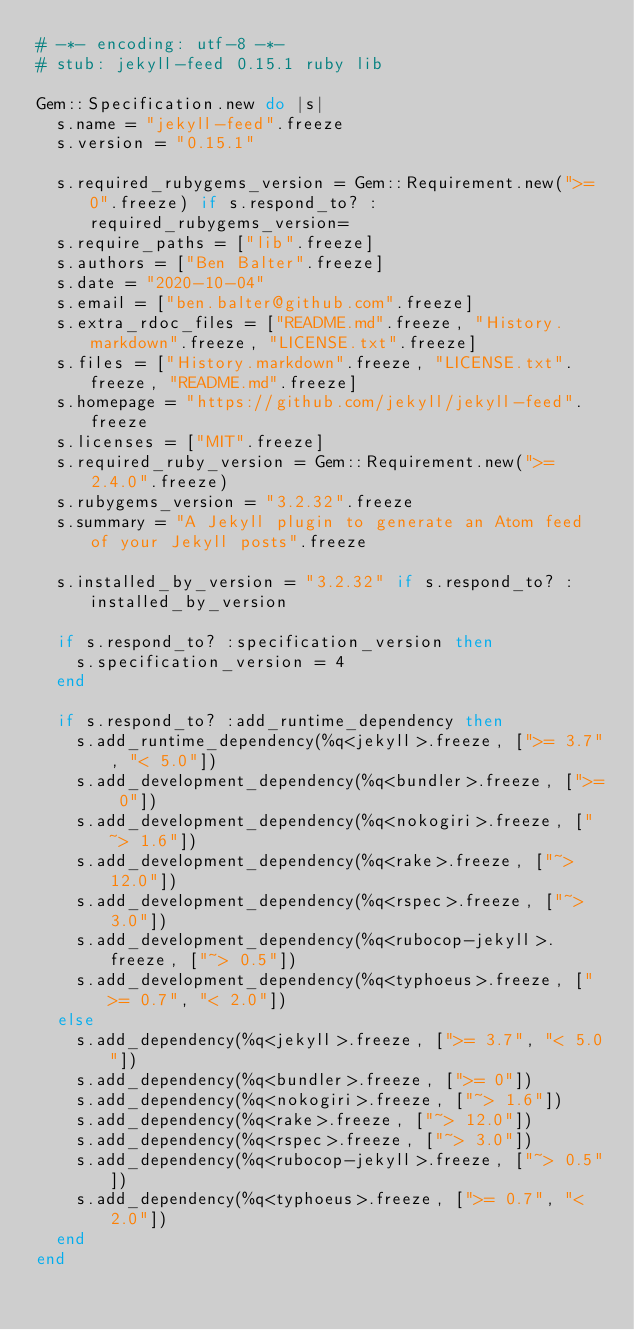Convert code to text. <code><loc_0><loc_0><loc_500><loc_500><_Ruby_># -*- encoding: utf-8 -*-
# stub: jekyll-feed 0.15.1 ruby lib

Gem::Specification.new do |s|
  s.name = "jekyll-feed".freeze
  s.version = "0.15.1"

  s.required_rubygems_version = Gem::Requirement.new(">= 0".freeze) if s.respond_to? :required_rubygems_version=
  s.require_paths = ["lib".freeze]
  s.authors = ["Ben Balter".freeze]
  s.date = "2020-10-04"
  s.email = ["ben.balter@github.com".freeze]
  s.extra_rdoc_files = ["README.md".freeze, "History.markdown".freeze, "LICENSE.txt".freeze]
  s.files = ["History.markdown".freeze, "LICENSE.txt".freeze, "README.md".freeze]
  s.homepage = "https://github.com/jekyll/jekyll-feed".freeze
  s.licenses = ["MIT".freeze]
  s.required_ruby_version = Gem::Requirement.new(">= 2.4.0".freeze)
  s.rubygems_version = "3.2.32".freeze
  s.summary = "A Jekyll plugin to generate an Atom feed of your Jekyll posts".freeze

  s.installed_by_version = "3.2.32" if s.respond_to? :installed_by_version

  if s.respond_to? :specification_version then
    s.specification_version = 4
  end

  if s.respond_to? :add_runtime_dependency then
    s.add_runtime_dependency(%q<jekyll>.freeze, [">= 3.7", "< 5.0"])
    s.add_development_dependency(%q<bundler>.freeze, [">= 0"])
    s.add_development_dependency(%q<nokogiri>.freeze, ["~> 1.6"])
    s.add_development_dependency(%q<rake>.freeze, ["~> 12.0"])
    s.add_development_dependency(%q<rspec>.freeze, ["~> 3.0"])
    s.add_development_dependency(%q<rubocop-jekyll>.freeze, ["~> 0.5"])
    s.add_development_dependency(%q<typhoeus>.freeze, [">= 0.7", "< 2.0"])
  else
    s.add_dependency(%q<jekyll>.freeze, [">= 3.7", "< 5.0"])
    s.add_dependency(%q<bundler>.freeze, [">= 0"])
    s.add_dependency(%q<nokogiri>.freeze, ["~> 1.6"])
    s.add_dependency(%q<rake>.freeze, ["~> 12.0"])
    s.add_dependency(%q<rspec>.freeze, ["~> 3.0"])
    s.add_dependency(%q<rubocop-jekyll>.freeze, ["~> 0.5"])
    s.add_dependency(%q<typhoeus>.freeze, [">= 0.7", "< 2.0"])
  end
end
</code> 